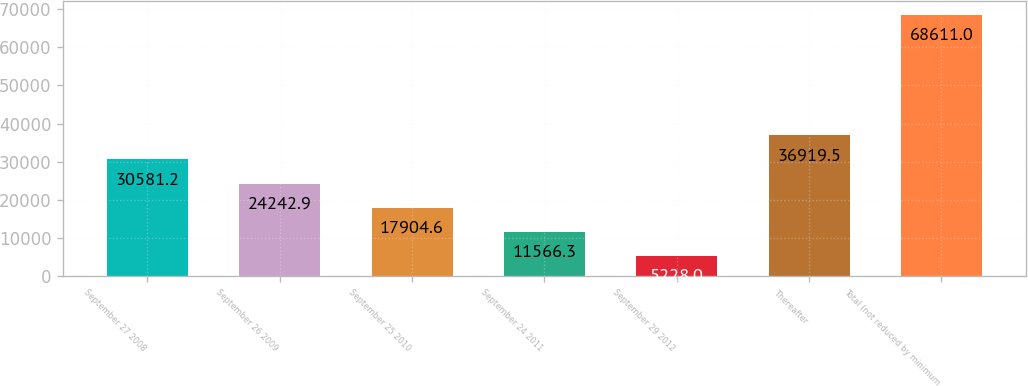Convert chart to OTSL. <chart><loc_0><loc_0><loc_500><loc_500><bar_chart><fcel>September 27 2008<fcel>September 26 2009<fcel>September 25 2010<fcel>September 24 2011<fcel>September 29 2012<fcel>Thereafter<fcel>Total (not reduced by minimum<nl><fcel>30581.2<fcel>24242.9<fcel>17904.6<fcel>11566.3<fcel>5228<fcel>36919.5<fcel>68611<nl></chart> 